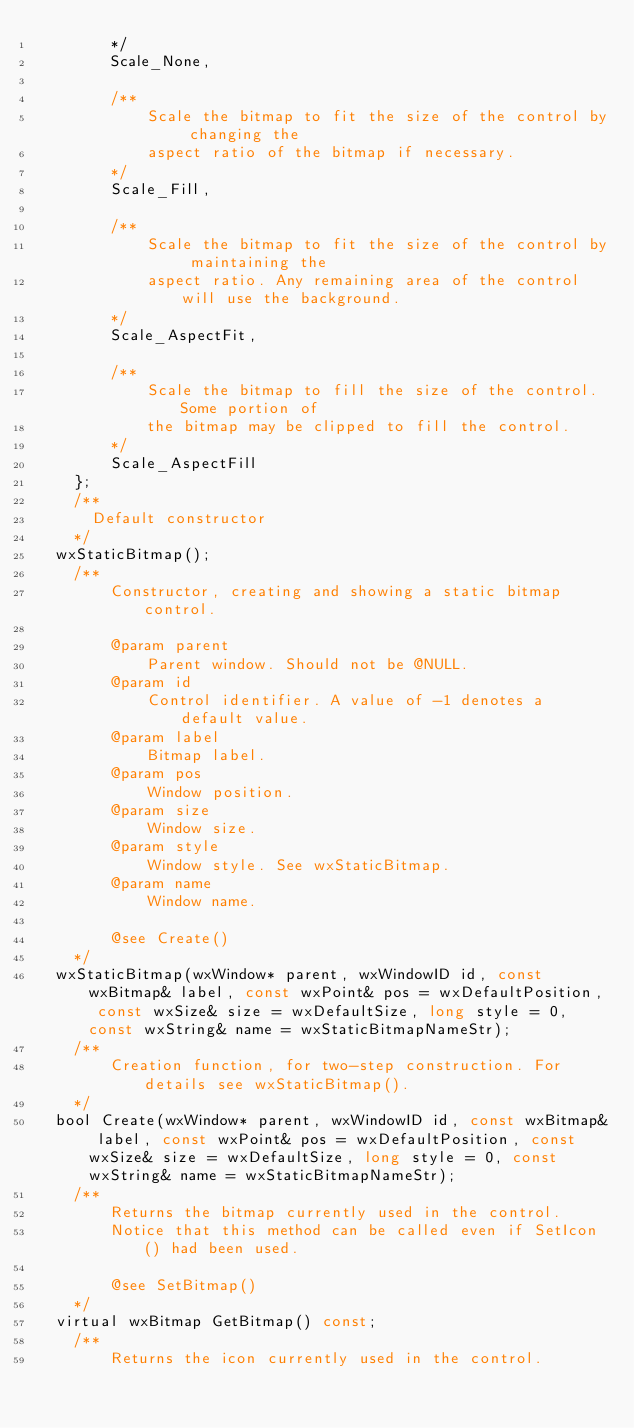<code> <loc_0><loc_0><loc_500><loc_500><_C_>        */
        Scale_None,
        
        /**
            Scale the bitmap to fit the size of the control by changing the
            aspect ratio of the bitmap if necessary.
        */
        Scale_Fill,
        
        /**
            Scale the bitmap to fit the size of the control by maintaining the
            aspect ratio. Any remaining area of the control will use the background.
        */
        Scale_AspectFit,
        
        /**
            Scale the bitmap to fill the size of the control. Some portion of
            the bitmap may be clipped to fill the control.
        */
        Scale_AspectFill
    };
    /**
      Default constructor
    */
  wxStaticBitmap();
    /**
        Constructor, creating and showing a static bitmap control.

        @param parent
            Parent window. Should not be @NULL.
        @param id
            Control identifier. A value of -1 denotes a default value.
        @param label
            Bitmap label.
        @param pos
            Window position.
        @param size
            Window size.
        @param style
            Window style. See wxStaticBitmap.
        @param name
            Window name.

        @see Create()
    */
  wxStaticBitmap(wxWindow* parent, wxWindowID id, const wxBitmap& label, const wxPoint& pos = wxDefaultPosition, const wxSize& size = wxDefaultSize, long style = 0, const wxString& name = wxStaticBitmapNameStr);
    /**
        Creation function, for two-step construction. For details see wxStaticBitmap().
    */
  bool Create(wxWindow* parent, wxWindowID id, const wxBitmap& label, const wxPoint& pos = wxDefaultPosition, const wxSize& size = wxDefaultSize, long style = 0, const wxString& name = wxStaticBitmapNameStr);
    /**
        Returns the bitmap currently used in the control.
        Notice that this method can be called even if SetIcon() had been used.

        @see SetBitmap()
    */
  virtual wxBitmap GetBitmap() const;
    /**
        Returns the icon currently used in the control.</code> 